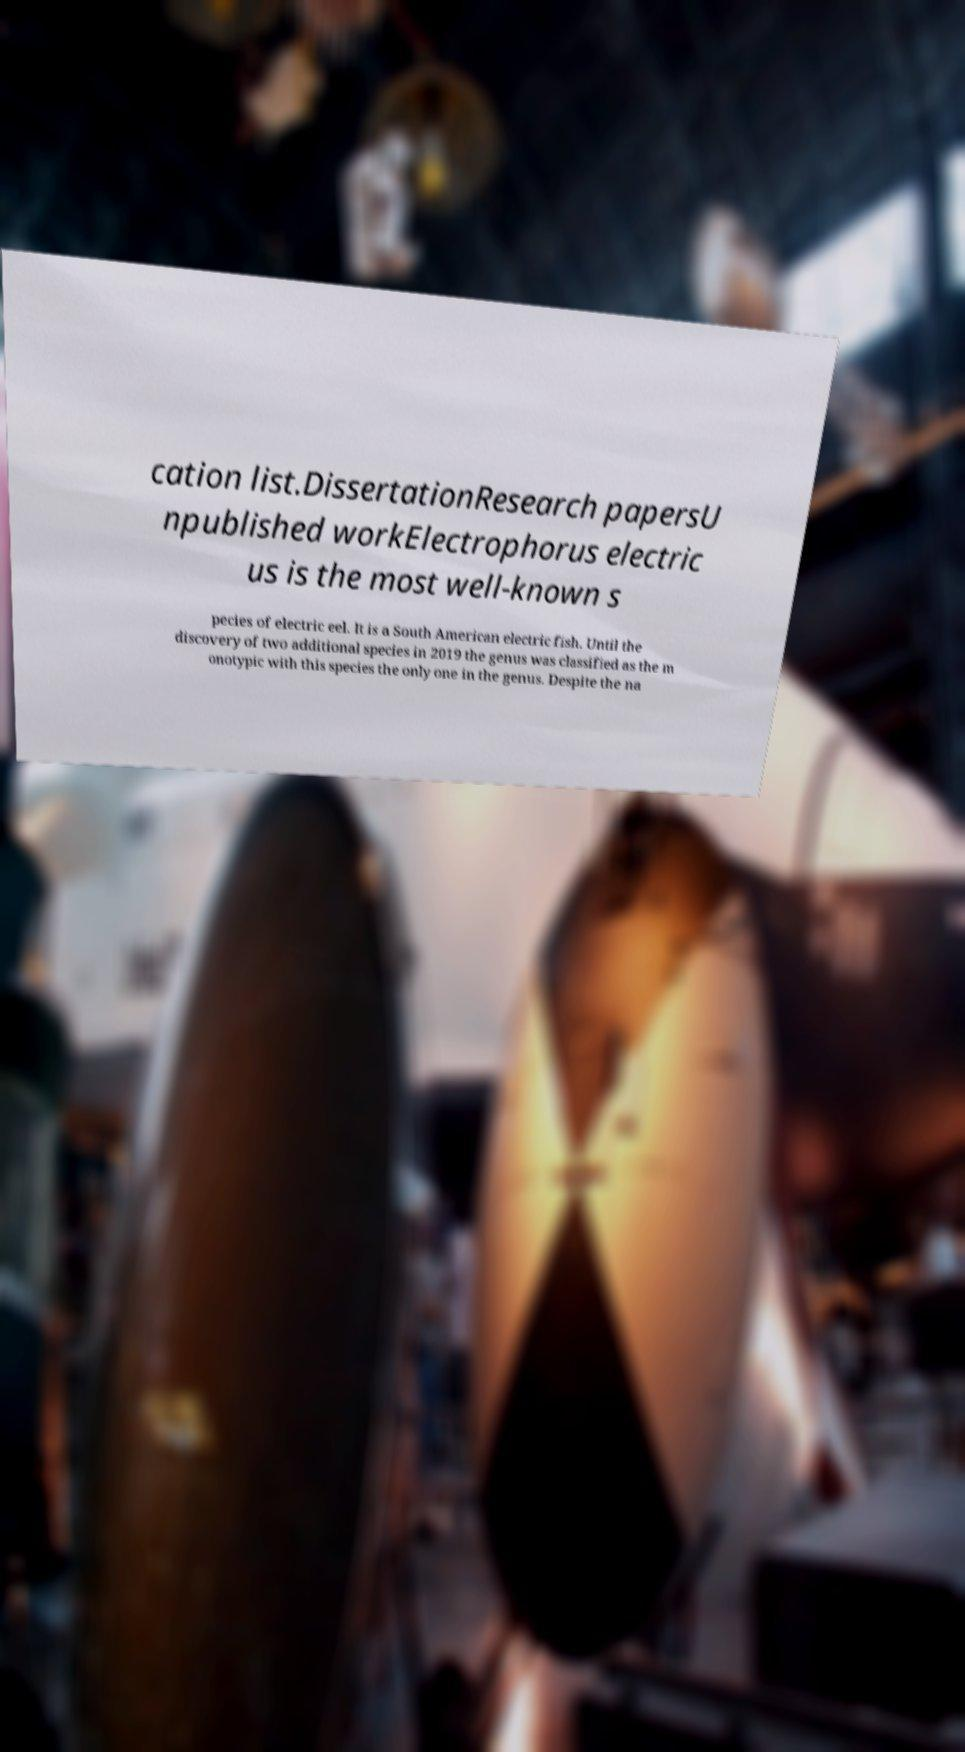For documentation purposes, I need the text within this image transcribed. Could you provide that? cation list.DissertationResearch papersU npublished workElectrophorus electric us is the most well-known s pecies of electric eel. It is a South American electric fish. Until the discovery of two additional species in 2019 the genus was classified as the m onotypic with this species the only one in the genus. Despite the na 